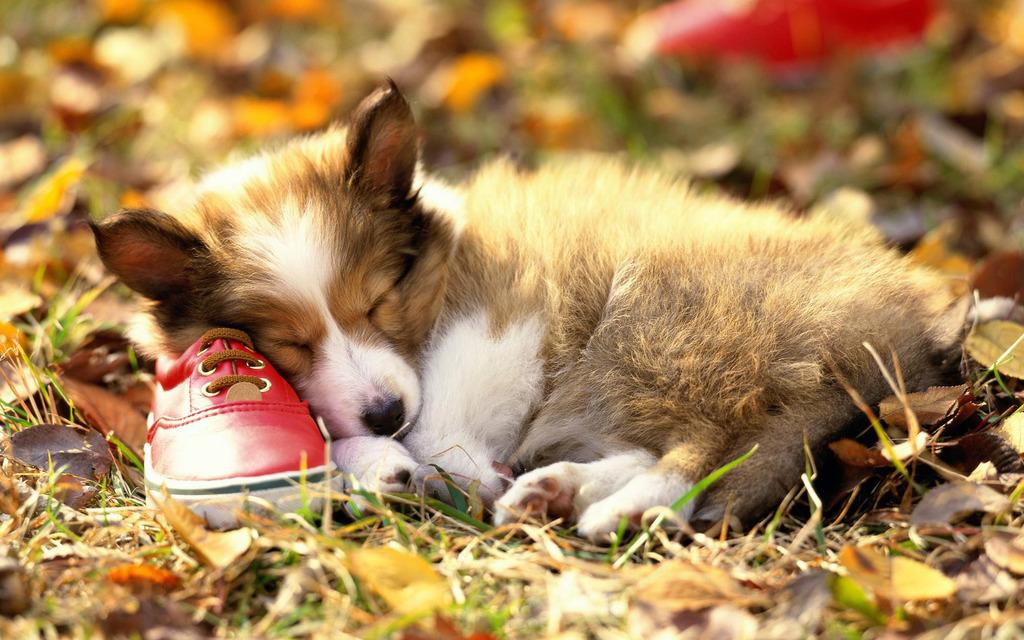What type of animal is in the image? There is a dog in the image. What is the condition of the dog in the image? The dog appears to be dying. What other object can be seen on the ground in the image? There is a shoe on the ground in the image. What type of vegetation is present in the image? Leaves are present in the image. How would you describe the background of the image? The background of the image is blurred. Can you identify any other objects in the background of the image? There is an object visible in the background. How many sisters are interacting with the dog in the image? There are no sisters present in the image; it only features a dog, a shoe, leaves, and a blurred background. What type of fiction is the dog reading in the image? There is no fiction present in the image, and the dog is not shown reading anything. 